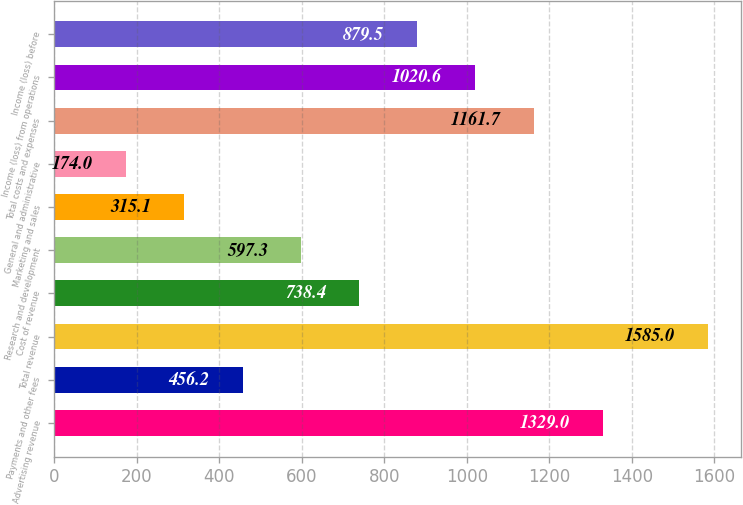<chart> <loc_0><loc_0><loc_500><loc_500><bar_chart><fcel>Advertising revenue<fcel>Payments and other fees<fcel>Total revenue<fcel>Cost of revenue<fcel>Research and development<fcel>Marketing and sales<fcel>General and administrative<fcel>Total costs and expenses<fcel>Income (loss) from operations<fcel>Income (loss) before<nl><fcel>1329<fcel>456.2<fcel>1585<fcel>738.4<fcel>597.3<fcel>315.1<fcel>174<fcel>1161.7<fcel>1020.6<fcel>879.5<nl></chart> 